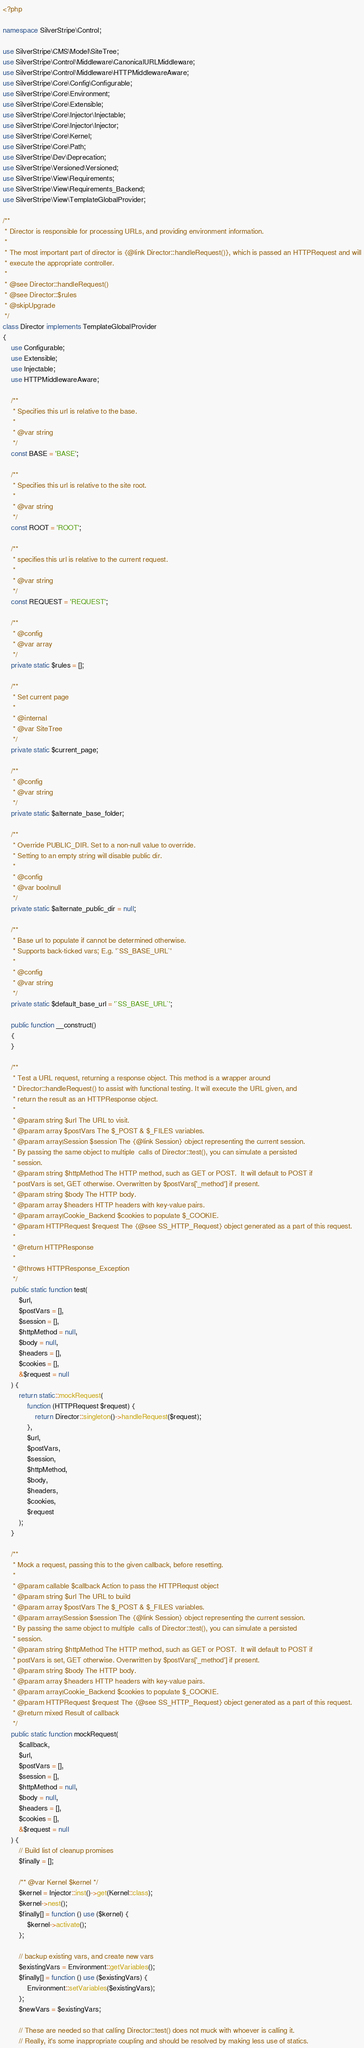<code> <loc_0><loc_0><loc_500><loc_500><_PHP_><?php

namespace SilverStripe\Control;

use SilverStripe\CMS\Model\SiteTree;
use SilverStripe\Control\Middleware\CanonicalURLMiddleware;
use SilverStripe\Control\Middleware\HTTPMiddlewareAware;
use SilverStripe\Core\Config\Configurable;
use SilverStripe\Core\Environment;
use SilverStripe\Core\Extensible;
use SilverStripe\Core\Injector\Injectable;
use SilverStripe\Core\Injector\Injector;
use SilverStripe\Core\Kernel;
use SilverStripe\Core\Path;
use SilverStripe\Dev\Deprecation;
use SilverStripe\Versioned\Versioned;
use SilverStripe\View\Requirements;
use SilverStripe\View\Requirements_Backend;
use SilverStripe\View\TemplateGlobalProvider;

/**
 * Director is responsible for processing URLs, and providing environment information.
 *
 * The most important part of director is {@link Director::handleRequest()}, which is passed an HTTPRequest and will
 * execute the appropriate controller.
 *
 * @see Director::handleRequest()
 * @see Director::$rules
 * @skipUpgrade
 */
class Director implements TemplateGlobalProvider
{
    use Configurable;
    use Extensible;
    use Injectable;
    use HTTPMiddlewareAware;

    /**
     * Specifies this url is relative to the base.
     *
     * @var string
     */
    const BASE = 'BASE';

    /**
     * Specifies this url is relative to the site root.
     *
     * @var string
     */
    const ROOT = 'ROOT';

    /**
     * specifies this url is relative to the current request.
     *
     * @var string
     */
    const REQUEST = 'REQUEST';

    /**
     * @config
     * @var array
     */
    private static $rules = [];

    /**
     * Set current page
     *
     * @internal
     * @var SiteTree
     */
    private static $current_page;

    /**
     * @config
     * @var string
     */
    private static $alternate_base_folder;

    /**
     * Override PUBLIC_DIR. Set to a non-null value to override.
     * Setting to an empty string will disable public dir.
     *
     * @config
     * @var bool|null
     */
    private static $alternate_public_dir = null;

    /**
     * Base url to populate if cannot be determined otherwise.
     * Supports back-ticked vars; E.g. '`SS_BASE_URL`'
     *
     * @config
     * @var string
     */
    private static $default_base_url = '`SS_BASE_URL`';

    public function __construct()
    {
    }

    /**
     * Test a URL request, returning a response object. This method is a wrapper around
     * Director::handleRequest() to assist with functional testing. It will execute the URL given, and
     * return the result as an HTTPResponse object.
     *
     * @param string $url The URL to visit.
     * @param array $postVars The $_POST & $_FILES variables.
     * @param array|Session $session The {@link Session} object representing the current session.
     * By passing the same object to multiple  calls of Director::test(), you can simulate a persisted
     * session.
     * @param string $httpMethod The HTTP method, such as GET or POST.  It will default to POST if
     * postVars is set, GET otherwise. Overwritten by $postVars['_method'] if present.
     * @param string $body The HTTP body.
     * @param array $headers HTTP headers with key-value pairs.
     * @param array|Cookie_Backend $cookies to populate $_COOKIE.
     * @param HTTPRequest $request The {@see SS_HTTP_Request} object generated as a part of this request.
     *
     * @return HTTPResponse
     *
     * @throws HTTPResponse_Exception
     */
    public static function test(
        $url,
        $postVars = [],
        $session = [],
        $httpMethod = null,
        $body = null,
        $headers = [],
        $cookies = [],
        &$request = null
    ) {
        return static::mockRequest(
            function (HTTPRequest $request) {
                return Director::singleton()->handleRequest($request);
            },
            $url,
            $postVars,
            $session,
            $httpMethod,
            $body,
            $headers,
            $cookies,
            $request
        );
    }

    /**
     * Mock a request, passing this to the given callback, before resetting.
     *
     * @param callable $callback Action to pass the HTTPRequst object
     * @param string $url The URL to build
     * @param array $postVars The $_POST & $_FILES variables.
     * @param array|Session $session The {@link Session} object representing the current session.
     * By passing the same object to multiple  calls of Director::test(), you can simulate a persisted
     * session.
     * @param string $httpMethod The HTTP method, such as GET or POST.  It will default to POST if
     * postVars is set, GET otherwise. Overwritten by $postVars['_method'] if present.
     * @param string $body The HTTP body.
     * @param array $headers HTTP headers with key-value pairs.
     * @param array|Cookie_Backend $cookies to populate $_COOKIE.
     * @param HTTPRequest $request The {@see SS_HTTP_Request} object generated as a part of this request.
     * @return mixed Result of callback
     */
    public static function mockRequest(
        $callback,
        $url,
        $postVars = [],
        $session = [],
        $httpMethod = null,
        $body = null,
        $headers = [],
        $cookies = [],
        &$request = null
    ) {
        // Build list of cleanup promises
        $finally = [];

        /** @var Kernel $kernel */
        $kernel = Injector::inst()->get(Kernel::class);
        $kernel->nest();
        $finally[] = function () use ($kernel) {
            $kernel->activate();
        };

        // backup existing vars, and create new vars
        $existingVars = Environment::getVariables();
        $finally[] = function () use ($existingVars) {
            Environment::setVariables($existingVars);
        };
        $newVars = $existingVars;

        // These are needed so that calling Director::test() does not muck with whoever is calling it.
        // Really, it's some inappropriate coupling and should be resolved by making less use of statics.</code> 